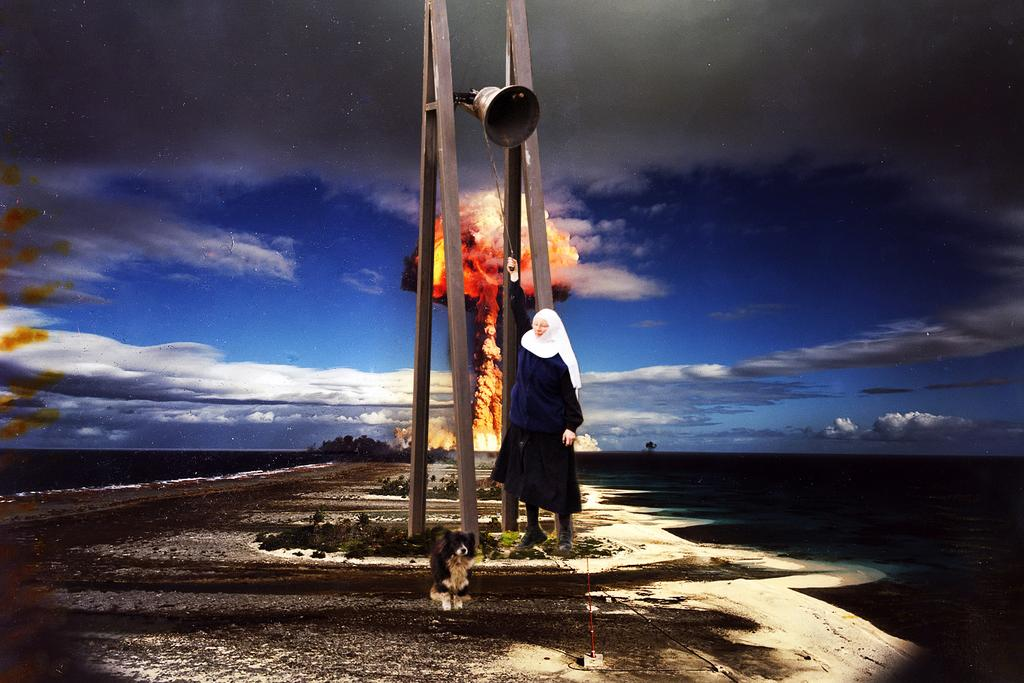What is the main subject of the image? There is a person standing in the image. What can be observed about the person's attire? The person is wearing clothes. What other living creature is present in the image? There is a dog in the image. What type of surface is visible in the image? There is a footpath in the image. What is the source of light in the image? There is a flame in the image. What type of vegetation is present in the image? There is grass in the image. How would you describe the weather in the image? The sky is cloudy in the image. Can you see any fairies flying around the person in the image? There are no fairies present in the image. What nerve does the person in the image have that allows them to control the flame? The image does not provide information about the person's nerves or their ability to control the flame. 